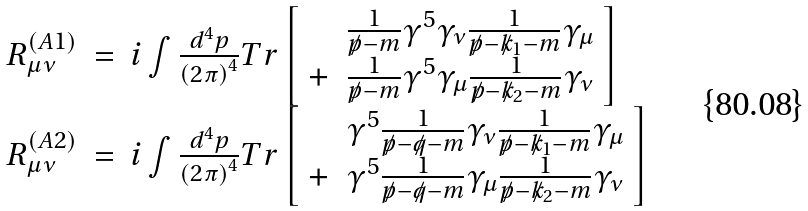<formula> <loc_0><loc_0><loc_500><loc_500>\begin{array} { r c l } R _ { \mu \nu } ^ { \left ( A 1 \right ) } & = & i \int \frac { d ^ { 4 } p } { \left ( 2 \pi \right ) ^ { 4 } } T r \left [ \begin{array} { r l } & \frac { 1 } { \not p - m } \gamma ^ { 5 } \gamma _ { \nu } \frac { 1 } { \not p - \not k _ { 1 } - m } \gamma _ { \mu } \\ + & \frac { 1 } { \not p - m } \gamma ^ { 5 } \gamma _ { \mu } \frac { 1 } { \not p - \not k _ { 2 } - m } \gamma _ { \nu } \end{array} \right ] \\ R _ { \mu \nu } ^ { \left ( A 2 \right ) } & = & i \int \frac { d ^ { 4 } p } { \left ( 2 \pi \right ) ^ { 4 } } T r \left [ \begin{array} { r l } & \gamma ^ { 5 } \frac { 1 } { \not p - \not q - m } \gamma _ { \nu } \frac { 1 } { \not p - \not k _ { 1 } - m } \gamma _ { \mu } \\ + & \gamma ^ { 5 } \frac { 1 } { \not p - \not q - m } \gamma _ { \mu } \frac { 1 } { \not p - \not k _ { 2 } - m } \gamma _ { \nu } \end{array} \right ] \end{array}</formula> 